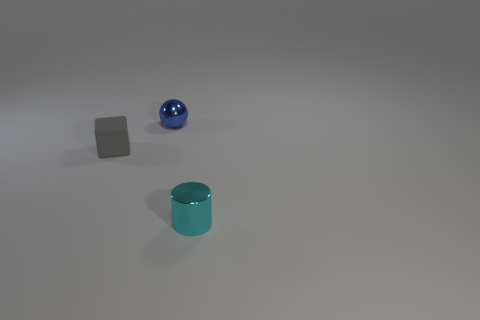Add 2 big rubber cylinders. How many objects exist? 5 Subtract all spheres. How many objects are left? 2 Add 3 blue metal things. How many blue metal things exist? 4 Subtract 0 green spheres. How many objects are left? 3 Subtract all tiny gray blocks. Subtract all blue shiny balls. How many objects are left? 1 Add 2 tiny gray objects. How many tiny gray objects are left? 3 